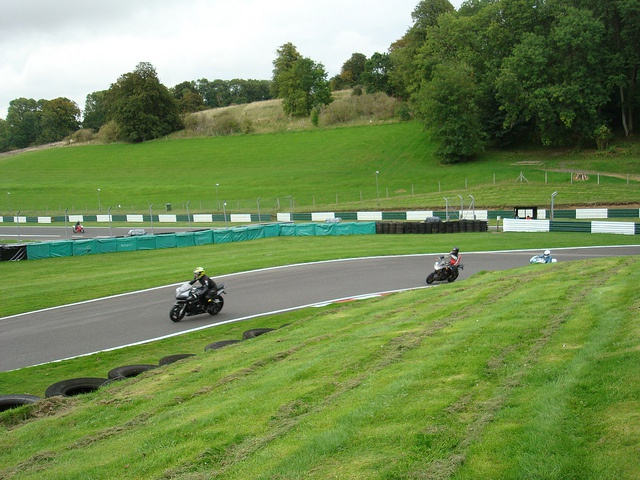Describe the objects in this image and their specific colors. I can see motorcycle in lightgray, black, gray, and darkgray tones, people in lightgray, black, gray, darkgray, and beige tones, motorcycle in lightgray, black, darkgray, gray, and white tones, people in lightgray, gray, darkgray, black, and brown tones, and people in lightgray, white, gray, and darkgray tones in this image. 